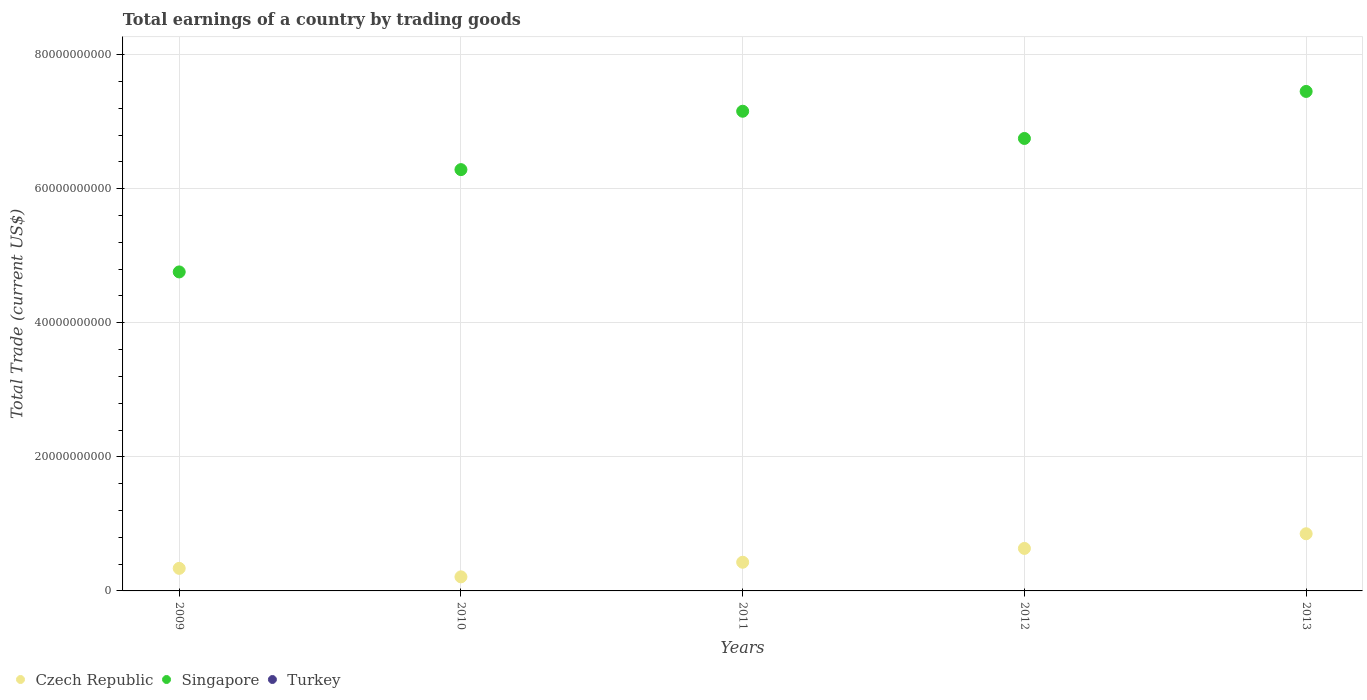Is the number of dotlines equal to the number of legend labels?
Your response must be concise. No. What is the total earnings in Singapore in 2009?
Your answer should be compact. 4.76e+1. Across all years, what is the maximum total earnings in Czech Republic?
Your response must be concise. 8.53e+09. In which year was the total earnings in Czech Republic maximum?
Your answer should be very brief. 2013. What is the total total earnings in Singapore in the graph?
Ensure brevity in your answer.  3.24e+11. What is the difference between the total earnings in Czech Republic in 2009 and that in 2012?
Offer a terse response. -2.97e+09. What is the difference between the total earnings in Singapore in 2011 and the total earnings in Czech Republic in 2013?
Ensure brevity in your answer.  6.30e+1. What is the average total earnings in Singapore per year?
Ensure brevity in your answer.  6.48e+1. In the year 2012, what is the difference between the total earnings in Czech Republic and total earnings in Singapore?
Give a very brief answer. -6.11e+1. In how many years, is the total earnings in Czech Republic greater than 52000000000 US$?
Your response must be concise. 0. What is the ratio of the total earnings in Singapore in 2010 to that in 2011?
Give a very brief answer. 0.88. What is the difference between the highest and the second highest total earnings in Singapore?
Provide a short and direct response. 2.95e+09. What is the difference between the highest and the lowest total earnings in Singapore?
Offer a very short reply. 2.69e+1. Does the total earnings in Turkey monotonically increase over the years?
Ensure brevity in your answer.  No. Is the total earnings in Singapore strictly greater than the total earnings in Czech Republic over the years?
Your response must be concise. Yes. How many dotlines are there?
Keep it short and to the point. 2. How many years are there in the graph?
Your answer should be very brief. 5. Are the values on the major ticks of Y-axis written in scientific E-notation?
Provide a succinct answer. No. Does the graph contain any zero values?
Provide a short and direct response. Yes. How are the legend labels stacked?
Provide a succinct answer. Horizontal. What is the title of the graph?
Your answer should be compact. Total earnings of a country by trading goods. What is the label or title of the Y-axis?
Offer a terse response. Total Trade (current US$). What is the Total Trade (current US$) of Czech Republic in 2009?
Keep it short and to the point. 3.37e+09. What is the Total Trade (current US$) of Singapore in 2009?
Offer a terse response. 4.76e+1. What is the Total Trade (current US$) in Czech Republic in 2010?
Ensure brevity in your answer.  2.10e+09. What is the Total Trade (current US$) in Singapore in 2010?
Keep it short and to the point. 6.28e+1. What is the Total Trade (current US$) in Turkey in 2010?
Give a very brief answer. 0. What is the Total Trade (current US$) of Czech Republic in 2011?
Provide a short and direct response. 4.28e+09. What is the Total Trade (current US$) of Singapore in 2011?
Keep it short and to the point. 7.15e+1. What is the Total Trade (current US$) in Czech Republic in 2012?
Give a very brief answer. 6.34e+09. What is the Total Trade (current US$) of Singapore in 2012?
Make the answer very short. 6.75e+1. What is the Total Trade (current US$) in Czech Republic in 2013?
Your answer should be compact. 8.53e+09. What is the Total Trade (current US$) of Singapore in 2013?
Make the answer very short. 7.45e+1. Across all years, what is the maximum Total Trade (current US$) in Czech Republic?
Provide a short and direct response. 8.53e+09. Across all years, what is the maximum Total Trade (current US$) of Singapore?
Your answer should be compact. 7.45e+1. Across all years, what is the minimum Total Trade (current US$) of Czech Republic?
Give a very brief answer. 2.10e+09. Across all years, what is the minimum Total Trade (current US$) in Singapore?
Offer a terse response. 4.76e+1. What is the total Total Trade (current US$) in Czech Republic in the graph?
Offer a very short reply. 2.46e+1. What is the total Total Trade (current US$) in Singapore in the graph?
Your answer should be very brief. 3.24e+11. What is the total Total Trade (current US$) in Turkey in the graph?
Your answer should be compact. 0. What is the difference between the Total Trade (current US$) of Czech Republic in 2009 and that in 2010?
Offer a terse response. 1.27e+09. What is the difference between the Total Trade (current US$) in Singapore in 2009 and that in 2010?
Give a very brief answer. -1.53e+1. What is the difference between the Total Trade (current US$) in Czech Republic in 2009 and that in 2011?
Offer a terse response. -9.11e+08. What is the difference between the Total Trade (current US$) of Singapore in 2009 and that in 2011?
Ensure brevity in your answer.  -2.40e+1. What is the difference between the Total Trade (current US$) in Czech Republic in 2009 and that in 2012?
Your answer should be very brief. -2.97e+09. What is the difference between the Total Trade (current US$) of Singapore in 2009 and that in 2012?
Offer a terse response. -1.99e+1. What is the difference between the Total Trade (current US$) in Czech Republic in 2009 and that in 2013?
Your response must be concise. -5.16e+09. What is the difference between the Total Trade (current US$) of Singapore in 2009 and that in 2013?
Your response must be concise. -2.69e+1. What is the difference between the Total Trade (current US$) of Czech Republic in 2010 and that in 2011?
Offer a very short reply. -2.18e+09. What is the difference between the Total Trade (current US$) of Singapore in 2010 and that in 2011?
Offer a terse response. -8.71e+09. What is the difference between the Total Trade (current US$) in Czech Republic in 2010 and that in 2012?
Keep it short and to the point. -4.24e+09. What is the difference between the Total Trade (current US$) in Singapore in 2010 and that in 2012?
Provide a short and direct response. -4.65e+09. What is the difference between the Total Trade (current US$) in Czech Republic in 2010 and that in 2013?
Your response must be concise. -6.43e+09. What is the difference between the Total Trade (current US$) in Singapore in 2010 and that in 2013?
Give a very brief answer. -1.17e+1. What is the difference between the Total Trade (current US$) in Czech Republic in 2011 and that in 2012?
Ensure brevity in your answer.  -2.06e+09. What is the difference between the Total Trade (current US$) in Singapore in 2011 and that in 2012?
Give a very brief answer. 4.06e+09. What is the difference between the Total Trade (current US$) in Czech Republic in 2011 and that in 2013?
Provide a short and direct response. -4.25e+09. What is the difference between the Total Trade (current US$) in Singapore in 2011 and that in 2013?
Provide a short and direct response. -2.95e+09. What is the difference between the Total Trade (current US$) in Czech Republic in 2012 and that in 2013?
Keep it short and to the point. -2.19e+09. What is the difference between the Total Trade (current US$) in Singapore in 2012 and that in 2013?
Your answer should be compact. -7.01e+09. What is the difference between the Total Trade (current US$) of Czech Republic in 2009 and the Total Trade (current US$) of Singapore in 2010?
Your answer should be very brief. -5.95e+1. What is the difference between the Total Trade (current US$) of Czech Republic in 2009 and the Total Trade (current US$) of Singapore in 2011?
Give a very brief answer. -6.82e+1. What is the difference between the Total Trade (current US$) in Czech Republic in 2009 and the Total Trade (current US$) in Singapore in 2012?
Offer a very short reply. -6.41e+1. What is the difference between the Total Trade (current US$) of Czech Republic in 2009 and the Total Trade (current US$) of Singapore in 2013?
Your answer should be very brief. -7.11e+1. What is the difference between the Total Trade (current US$) of Czech Republic in 2010 and the Total Trade (current US$) of Singapore in 2011?
Provide a succinct answer. -6.94e+1. What is the difference between the Total Trade (current US$) in Czech Republic in 2010 and the Total Trade (current US$) in Singapore in 2012?
Your answer should be very brief. -6.54e+1. What is the difference between the Total Trade (current US$) of Czech Republic in 2010 and the Total Trade (current US$) of Singapore in 2013?
Offer a very short reply. -7.24e+1. What is the difference between the Total Trade (current US$) of Czech Republic in 2011 and the Total Trade (current US$) of Singapore in 2012?
Provide a succinct answer. -6.32e+1. What is the difference between the Total Trade (current US$) in Czech Republic in 2011 and the Total Trade (current US$) in Singapore in 2013?
Offer a very short reply. -7.02e+1. What is the difference between the Total Trade (current US$) in Czech Republic in 2012 and the Total Trade (current US$) in Singapore in 2013?
Offer a terse response. -6.82e+1. What is the average Total Trade (current US$) in Czech Republic per year?
Give a very brief answer. 4.92e+09. What is the average Total Trade (current US$) of Singapore per year?
Offer a very short reply. 6.48e+1. What is the average Total Trade (current US$) in Turkey per year?
Your response must be concise. 0. In the year 2009, what is the difference between the Total Trade (current US$) in Czech Republic and Total Trade (current US$) in Singapore?
Your answer should be compact. -4.42e+1. In the year 2010, what is the difference between the Total Trade (current US$) in Czech Republic and Total Trade (current US$) in Singapore?
Ensure brevity in your answer.  -6.07e+1. In the year 2011, what is the difference between the Total Trade (current US$) in Czech Republic and Total Trade (current US$) in Singapore?
Make the answer very short. -6.73e+1. In the year 2012, what is the difference between the Total Trade (current US$) of Czech Republic and Total Trade (current US$) of Singapore?
Keep it short and to the point. -6.11e+1. In the year 2013, what is the difference between the Total Trade (current US$) in Czech Republic and Total Trade (current US$) in Singapore?
Your response must be concise. -6.60e+1. What is the ratio of the Total Trade (current US$) in Czech Republic in 2009 to that in 2010?
Your response must be concise. 1.6. What is the ratio of the Total Trade (current US$) of Singapore in 2009 to that in 2010?
Ensure brevity in your answer.  0.76. What is the ratio of the Total Trade (current US$) of Czech Republic in 2009 to that in 2011?
Your answer should be compact. 0.79. What is the ratio of the Total Trade (current US$) in Singapore in 2009 to that in 2011?
Ensure brevity in your answer.  0.67. What is the ratio of the Total Trade (current US$) in Czech Republic in 2009 to that in 2012?
Your answer should be very brief. 0.53. What is the ratio of the Total Trade (current US$) in Singapore in 2009 to that in 2012?
Ensure brevity in your answer.  0.7. What is the ratio of the Total Trade (current US$) in Czech Republic in 2009 to that in 2013?
Make the answer very short. 0.39. What is the ratio of the Total Trade (current US$) of Singapore in 2009 to that in 2013?
Offer a very short reply. 0.64. What is the ratio of the Total Trade (current US$) in Czech Republic in 2010 to that in 2011?
Your answer should be compact. 0.49. What is the ratio of the Total Trade (current US$) of Singapore in 2010 to that in 2011?
Your response must be concise. 0.88. What is the ratio of the Total Trade (current US$) in Czech Republic in 2010 to that in 2012?
Ensure brevity in your answer.  0.33. What is the ratio of the Total Trade (current US$) in Singapore in 2010 to that in 2012?
Provide a succinct answer. 0.93. What is the ratio of the Total Trade (current US$) in Czech Republic in 2010 to that in 2013?
Keep it short and to the point. 0.25. What is the ratio of the Total Trade (current US$) in Singapore in 2010 to that in 2013?
Offer a terse response. 0.84. What is the ratio of the Total Trade (current US$) in Czech Republic in 2011 to that in 2012?
Provide a succinct answer. 0.67. What is the ratio of the Total Trade (current US$) of Singapore in 2011 to that in 2012?
Give a very brief answer. 1.06. What is the ratio of the Total Trade (current US$) of Czech Republic in 2011 to that in 2013?
Make the answer very short. 0.5. What is the ratio of the Total Trade (current US$) of Singapore in 2011 to that in 2013?
Keep it short and to the point. 0.96. What is the ratio of the Total Trade (current US$) of Czech Republic in 2012 to that in 2013?
Give a very brief answer. 0.74. What is the ratio of the Total Trade (current US$) of Singapore in 2012 to that in 2013?
Offer a terse response. 0.91. What is the difference between the highest and the second highest Total Trade (current US$) in Czech Republic?
Offer a very short reply. 2.19e+09. What is the difference between the highest and the second highest Total Trade (current US$) in Singapore?
Provide a short and direct response. 2.95e+09. What is the difference between the highest and the lowest Total Trade (current US$) in Czech Republic?
Provide a succinct answer. 6.43e+09. What is the difference between the highest and the lowest Total Trade (current US$) in Singapore?
Provide a short and direct response. 2.69e+1. 